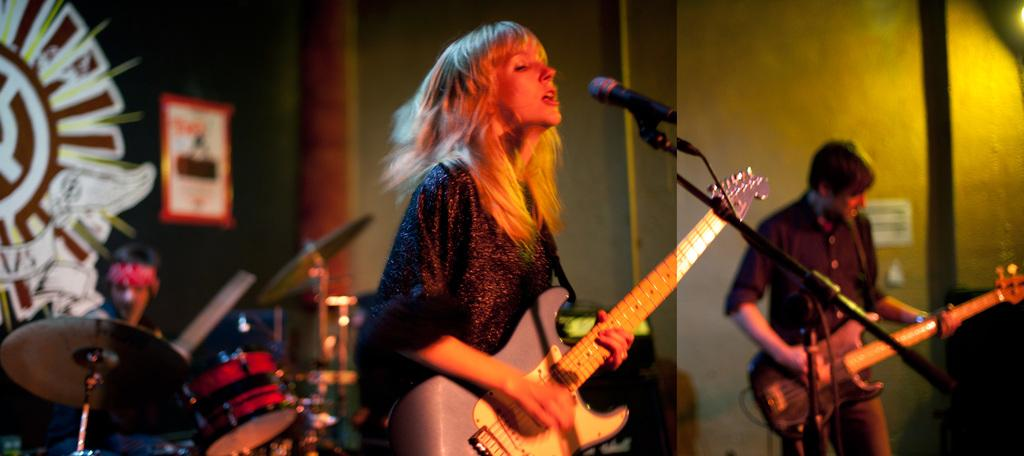What is the man in the image doing? The man is playing a guitar. What is the woman in the image doing? The woman is playing a guitar and singing with the help of a microphone. What is the seated man in the image doing? The seated man is playing drums. How many musicians are present in the image? There are three musicians in the image. What is the name of the fictional character that appears in the image? There is no fictional character present in the image; it features real people playing musical instruments. What type of arch can be seen in the image? There is no arch present in the image. 